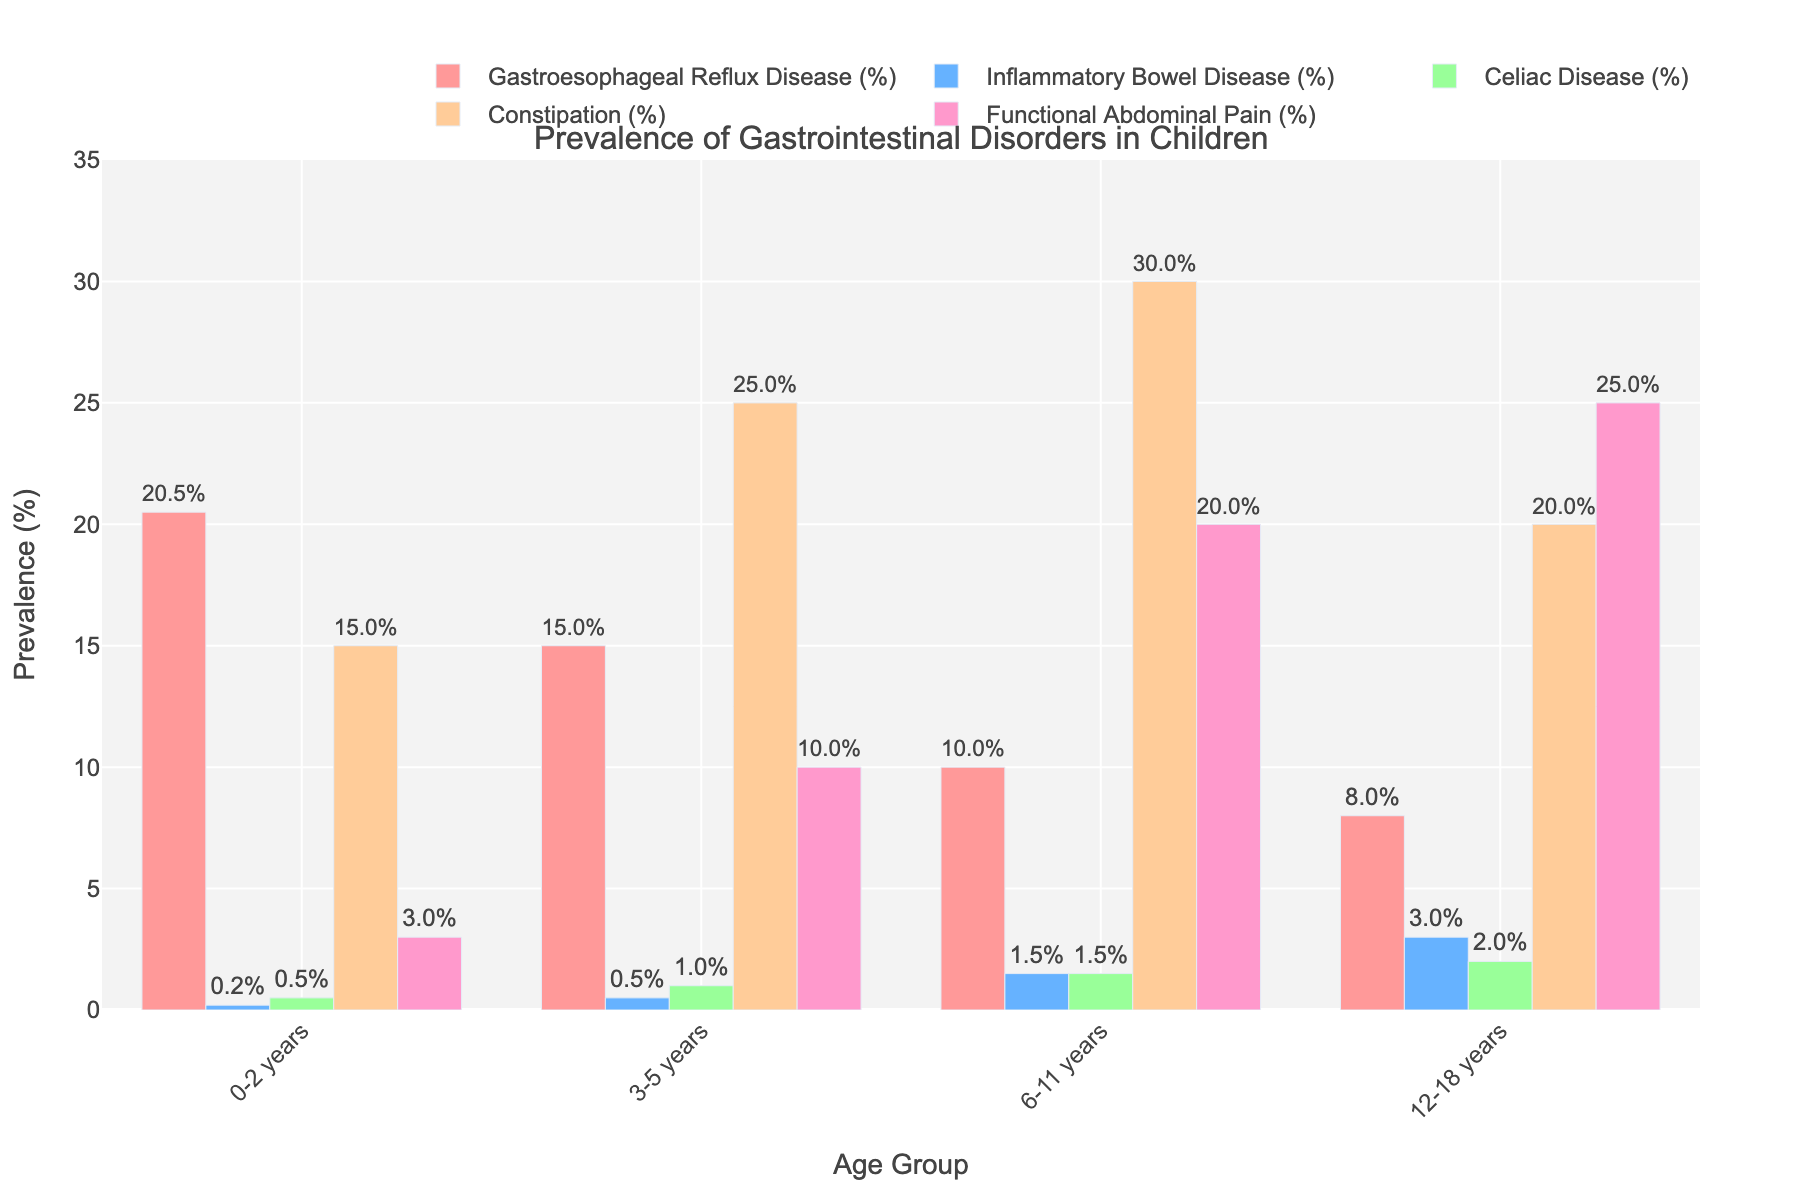What is the prevalence of Functional Abdominal Pain in children aged 6-11 years? Look at the chart and find the bar labeled "Functional Abdominal Pain" for the age group "6-11 years". The value at the top of the bar indicates the percentage.
Answer: 20.0% Which age group has the highest prevalence of Constipation? To determine this, compare the heights of the bars labeled "Constipation" across all age groups. The highest bar represents the group with the highest prevalence.
Answer: 6-11 years What is the difference in prevalence of Gastroesophageal Reflux Disease between the age groups 0-2 years and 12-18 years? Find the bars labeled "Gastroesophageal Reflux Disease" for both age groups "0-2 years" and "12-18 years". Subtract the prevalence of the latter from the former.
Answer: 12.5% Which gastrointestinal disorder has the lowest prevalence in children aged 3-5 years? To identify this, look at the bars for all disorders in the age group "3-5 years". The shortest bar indicates the disorder with the lowest prevalence.
Answer: Gastroesophageal Reflux Disease If you sum the prevalence rates of Celiac Disease across all age groups, what is the total percentage? Add the prevalence percentages of "Celiac Disease" from all age groups (0-2 years, 3-5 years, 6-11 years, 12-18 years). The total gives the combined prevalence.
Answer: 5.0% How does the prevalence of Inflammatory Bowel Disease compare between the age groups 6-11 years and 12-18 years? Compare the heights of the bars labeled "Inflammatory Bowel Disease" for the age groups "6-11 years" and "12-18 years". The bar that is higher represents the group with the greater prevalence.
Answer: 12-18 years Which disorder has a higher prevalence in children aged 0-2 years, Constipation or Functional Abdominal Pain? Look at the bars labeled "Constipation" and "Functional Abdominal Pain" for the age group "0-2 years". Compare their heights to determine which is higher.
Answer: Constipation What is the average prevalence of Gastroesophageal Reflux Disease across all age groups? Add the prevalence percentages for "Gastroesophageal Reflux Disease" in all age groups (20.5 + 15.0 + 10.0 + 8.0). Divide the total by the number of age groups (4) to find the average.
Answer: 13.375% 